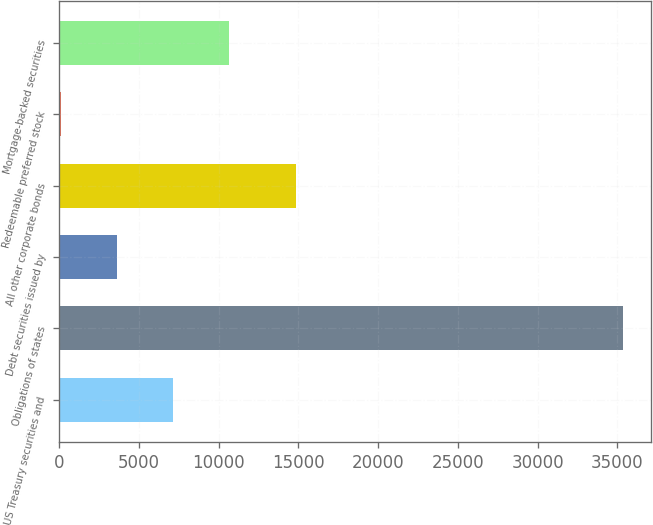Convert chart to OTSL. <chart><loc_0><loc_0><loc_500><loc_500><bar_chart><fcel>US Treasury securities and<fcel>Obligations of states<fcel>Debt securities issued by<fcel>All other corporate bonds<fcel>Redeemable preferred stock<fcel>Mortgage-backed securities<nl><fcel>7146<fcel>35326<fcel>3623.5<fcel>14866<fcel>101<fcel>10668.5<nl></chart> 